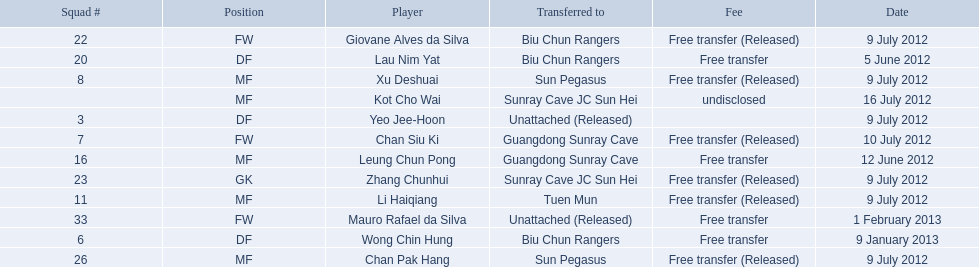On what dates were there non released free transfers? 5 June 2012, 12 June 2012, 9 January 2013, 1 February 2013. On which of these were the players transferred to another team? 5 June 2012, 12 June 2012, 9 January 2013. Which of these were the transfers to biu chun rangers? 5 June 2012, 9 January 2013. On which of those dated did they receive a df? 9 January 2013. 